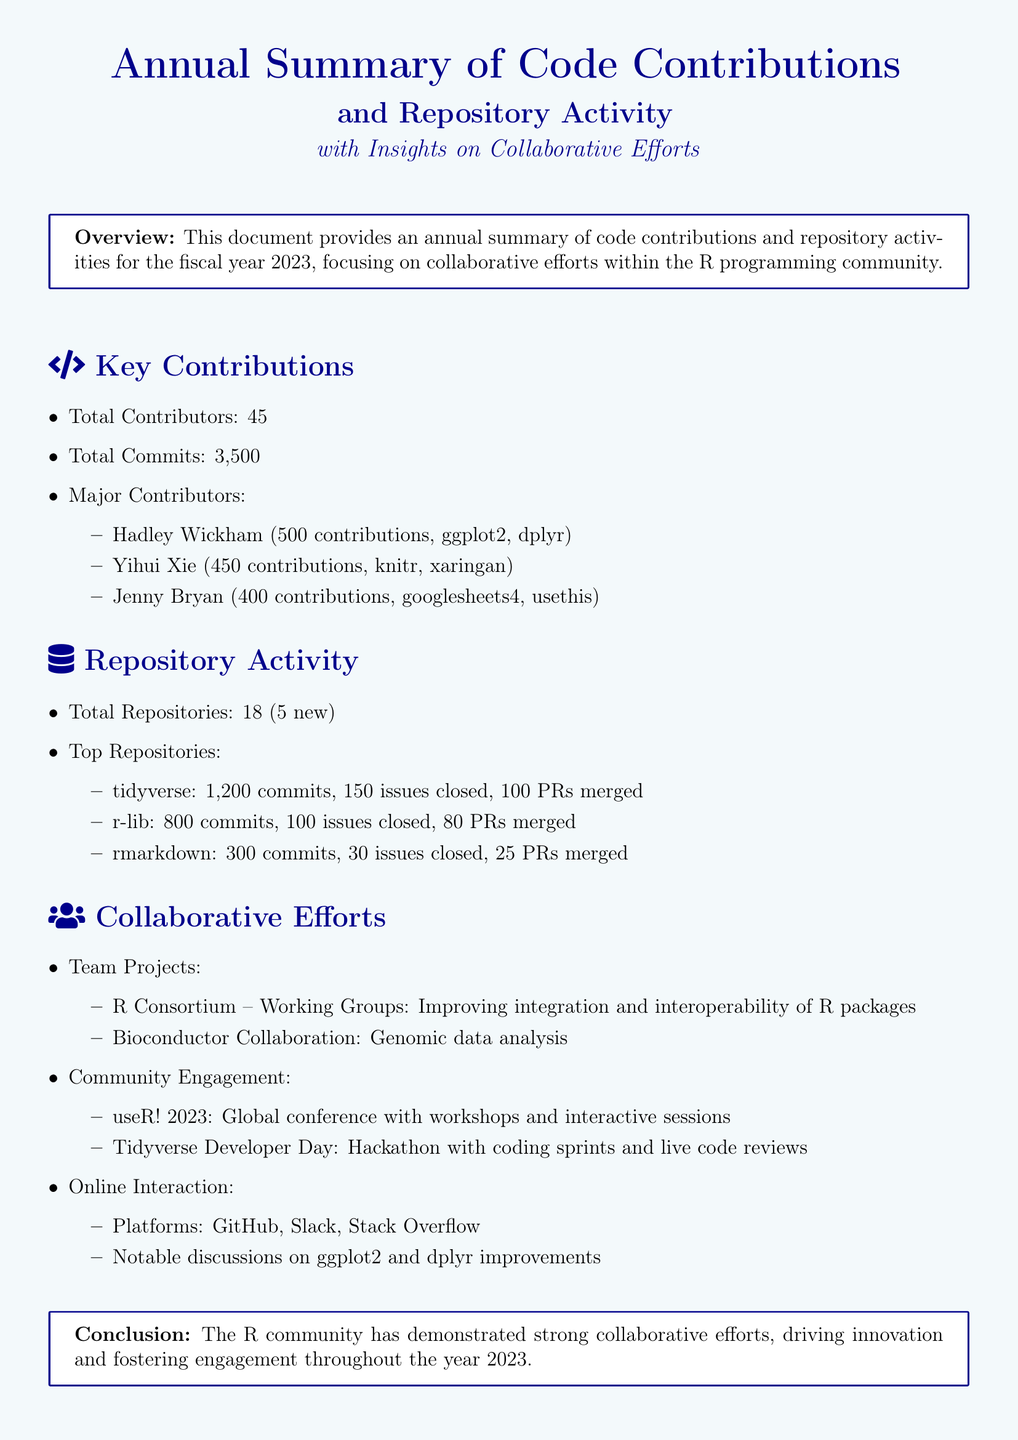What is the total number of contributors? The document states that there are 45 total contributors mentioned in the section about Key Contributions.
Answer: 45 Who is the major contributor with the highest contributions? Hadley Wickham is listed as the major contributor with 500 contributions in the Key Contributions section.
Answer: Hadley Wickham How many total commits were made? The total number of commits, as indicated in the Key Contributions section, is 3,500.
Answer: 3,500 What is the top repository by commits? The document identifies 'tidyverse' as the top repository with 1,200 commits in the Repository Activity section.
Answer: tidyverse How many new repositories were added? According to the Repository Activity section, the total number of new repositories is 5.
Answer: 5 What was the main focus of the R Consortium working groups? The R Consortium working groups focus on improving integration and interoperability of R packages, as mentioned in the Collaborative Efforts section.
Answer: Improving integration and interoperability of R packages What global event contributed to community engagement? The document refers to useR! 2023 as the global event that contributed to community engagement in the Collaborative Efforts section.
Answer: useR! 2023 How many issues were closed in the r-lib repository? The Repository Activity section indicates that the r-lib repository closed 100 issues.
Answer: 100 What year does this annual summary cover? The Overview section specifies that the annual summary covers the fiscal year 2023.
Answer: 2023 